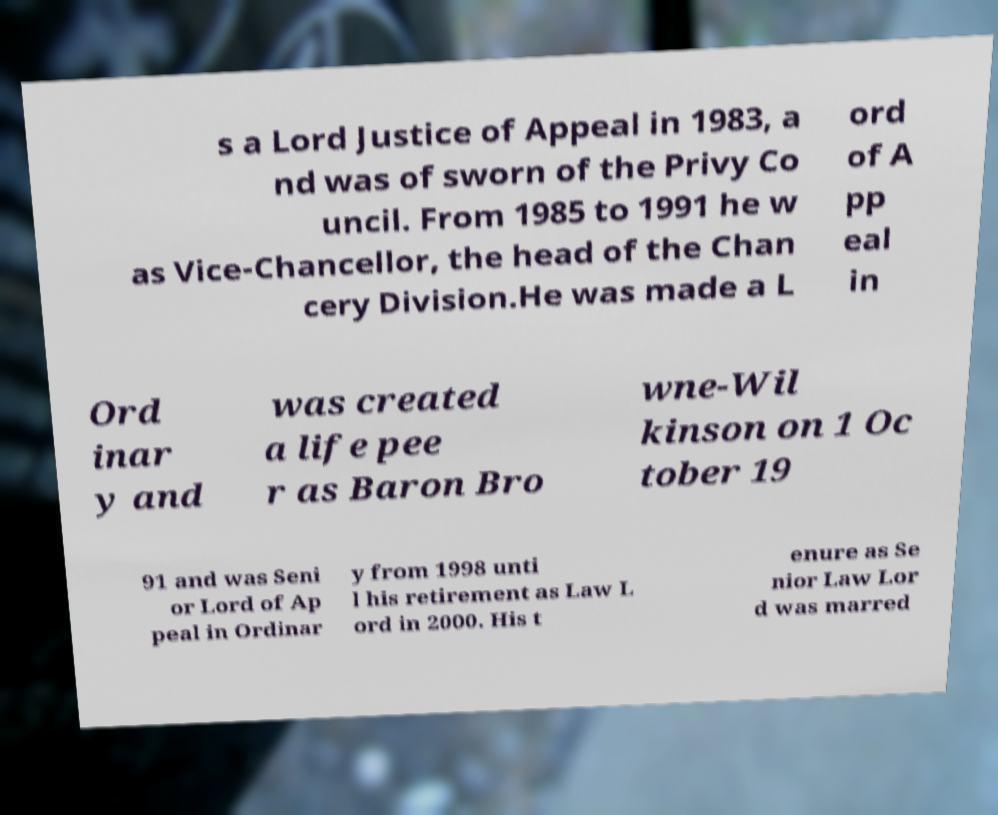I need the written content from this picture converted into text. Can you do that? s a Lord Justice of Appeal in 1983, a nd was of sworn of the Privy Co uncil. From 1985 to 1991 he w as Vice-Chancellor, the head of the Chan cery Division.He was made a L ord of A pp eal in Ord inar y and was created a life pee r as Baron Bro wne-Wil kinson on 1 Oc tober 19 91 and was Seni or Lord of Ap peal in Ordinar y from 1998 unti l his retirement as Law L ord in 2000. His t enure as Se nior Law Lor d was marred 